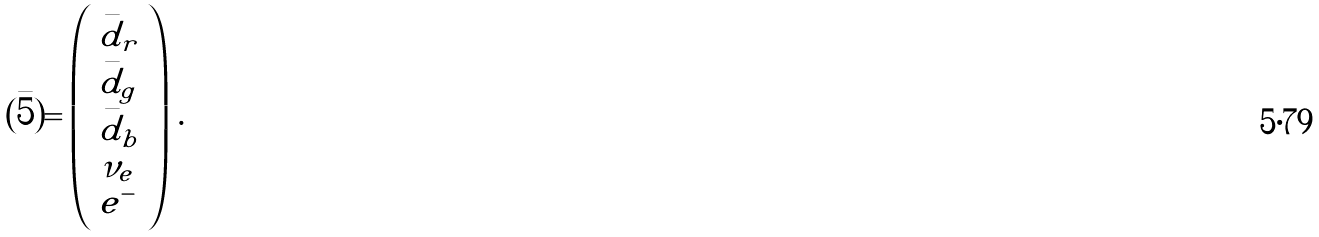Convert formula to latex. <formula><loc_0><loc_0><loc_500><loc_500>( \bar { 5 } ) = \left ( \begin{array} { l } \bar { d } _ { r } \\ \bar { d } _ { g } \\ \bar { d } _ { b } \\ \nu _ { e } \\ e ^ { - } \end{array} \right ) \, .</formula> 